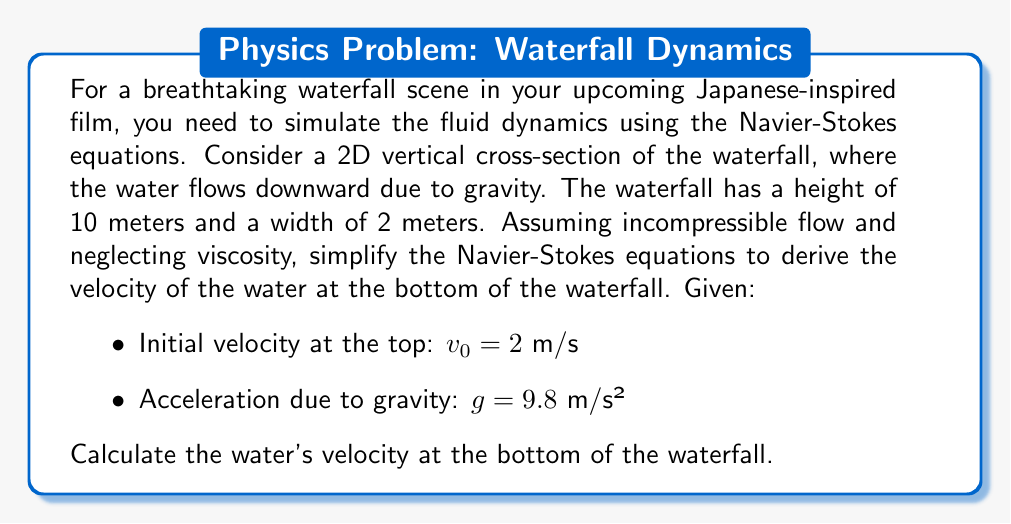Teach me how to tackle this problem. To solve this problem, we'll use a simplified version of the Navier-Stokes equations for incompressible, inviscid flow in a vertical direction. This simplification leads us to use Bernoulli's equation along a streamline.

1. The simplified Navier-Stokes equation for this scenario is essentially the equation of motion for a falling object:

   $$\frac{dv}{dt} = g$$

2. We can integrate this equation with respect to time, but it's more convenient to use the principle of conservation of energy, which is embodied in Bernoulli's equation:

   $$P_1 + \frac{1}{2}\rho v_1^2 + \rho gh_1 = P_2 + \frac{1}{2}\rho v_2^2 + \rho gh_2$$

   Where:
   - $P$ is pressure
   - $\rho$ is density
   - $v$ is velocity
   - $g$ is acceleration due to gravity
   - $h$ is height

3. At both the top and bottom of the waterfall, the water is exposed to atmospheric pressure, so $P_1 = P_2$. We can cancel these terms.

4. Let's define the top of the waterfall as point 1 and the bottom as point 2. The height difference is 10 meters, so $h_1 - h_2 = 10$ m.

5. Simplifying Bernoulli's equation:

   $$\frac{1}{2}v_1^2 + gh_1 = \frac{1}{2}v_2^2 + gh_2$$

6. Rearranging to solve for $v_2$:

   $$v_2^2 = v_1^2 + 2g(h_1 - h_2)$$

7. Substituting the known values:

   $$v_2^2 = (2 \text{ m/s})^2 + 2(9.8 \text{ m/s}^2)(10 \text{ m})$$

8. Solving:

   $$v_2^2 = 4 + 196 = 200 \text{ m}^2/\text{s}^2$$

9. Taking the square root:

   $$v_2 = \sqrt{200} \approx 14.14 \text{ m/s}$$

This result gives us the theoretical velocity of the water at the bottom of the waterfall, assuming no energy losses due to air resistance or friction.
Answer: The velocity of the water at the bottom of the waterfall is approximately 14.14 m/s. 